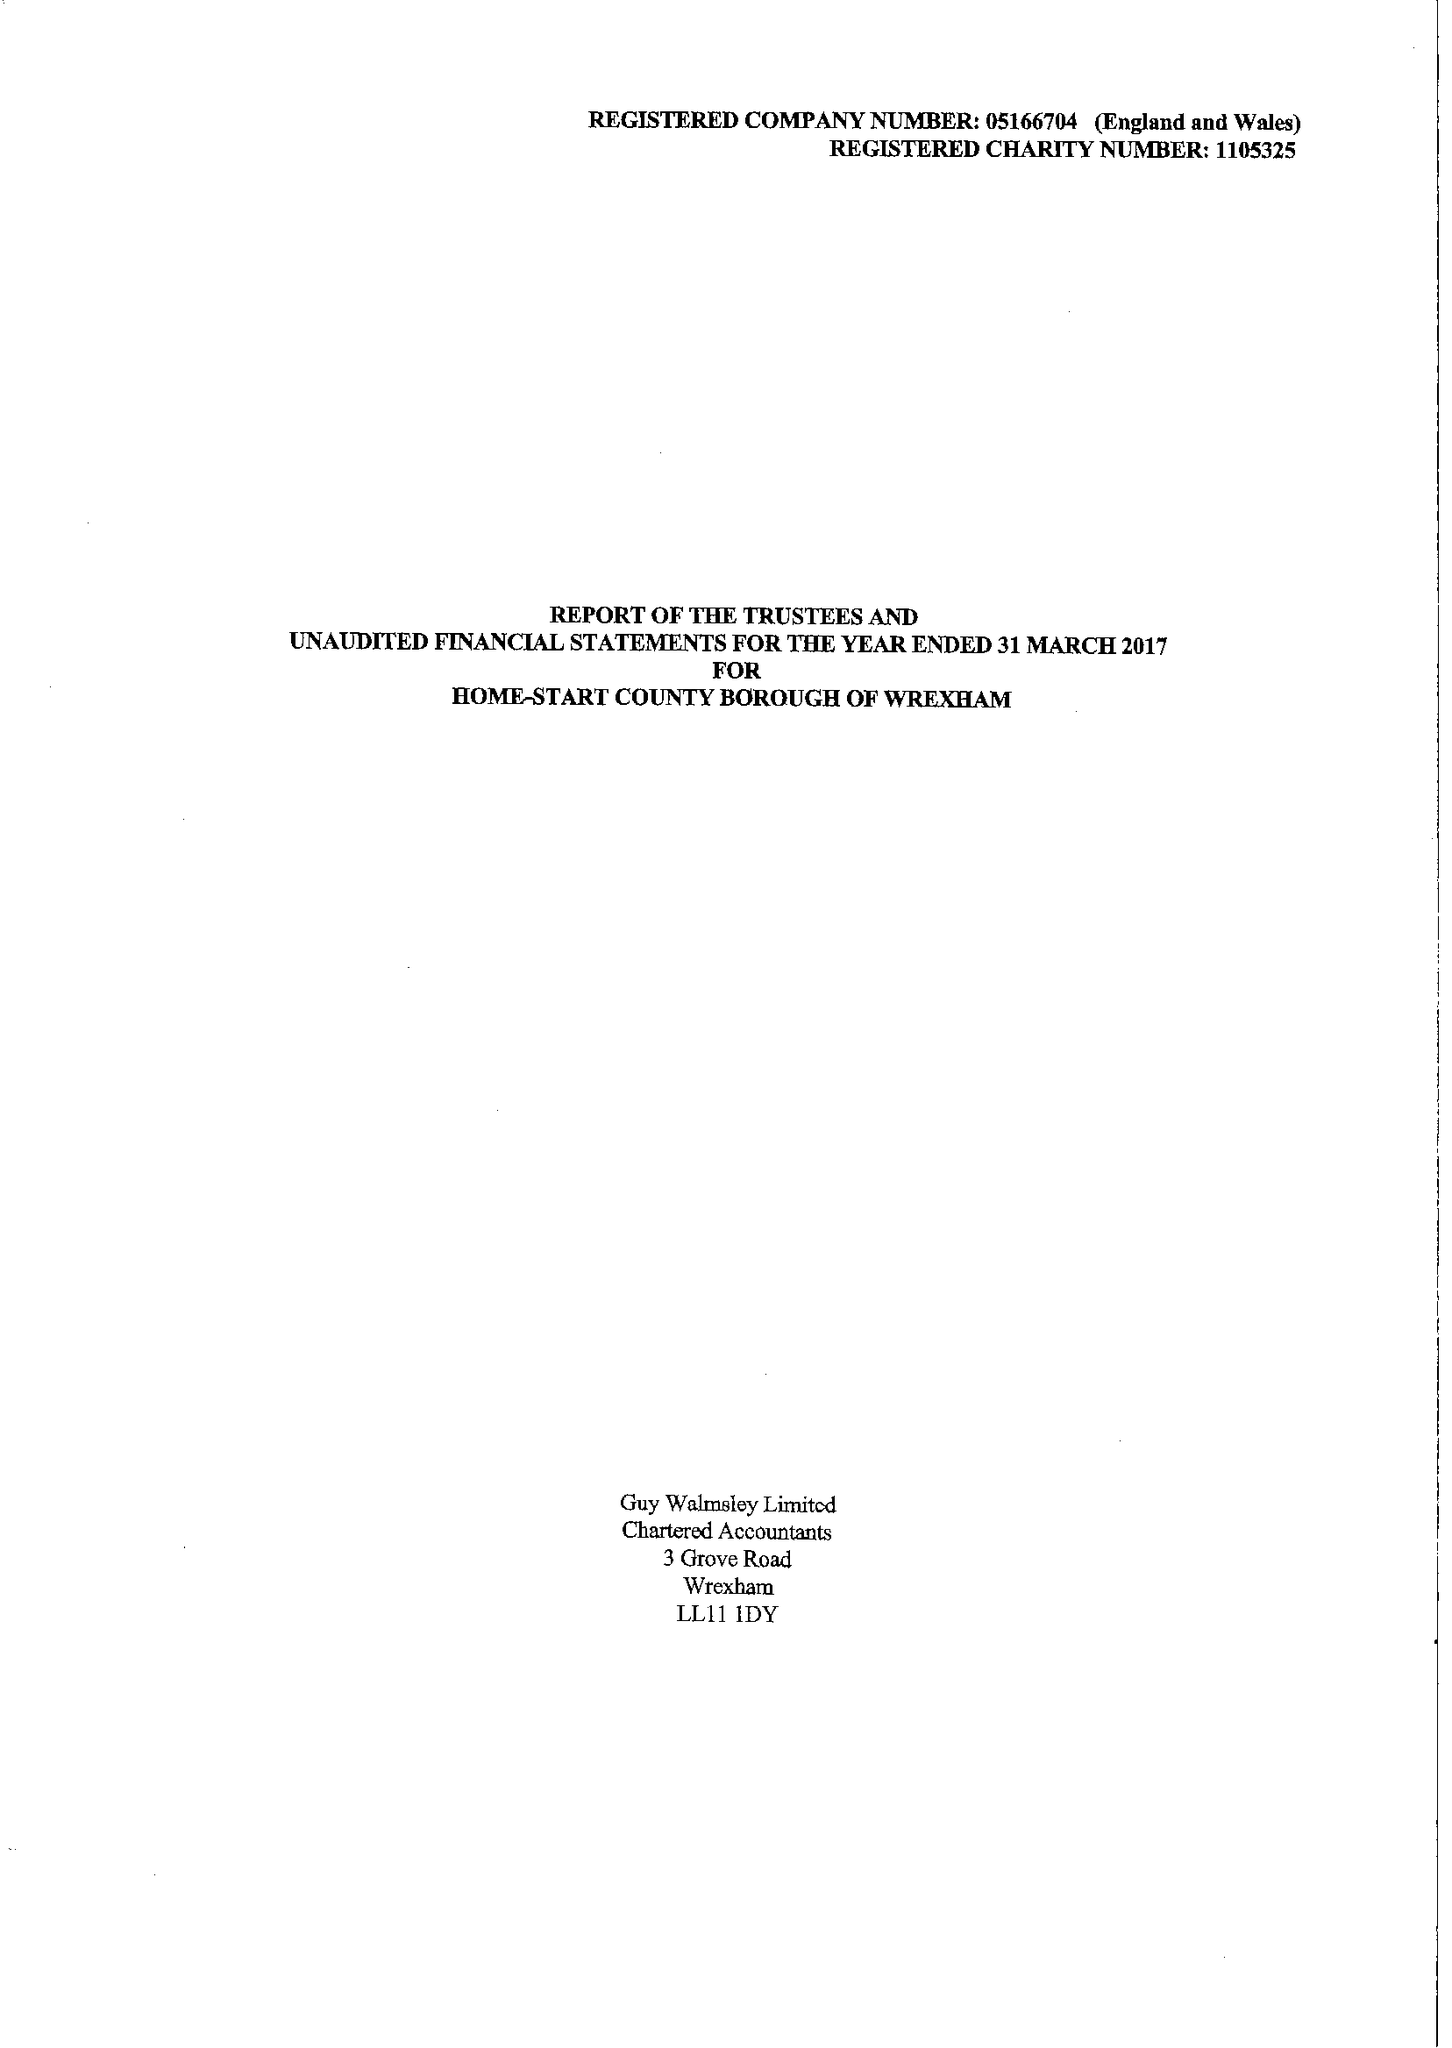What is the value for the address__postcode?
Answer the question using a single word or phrase. LL11 2NU 